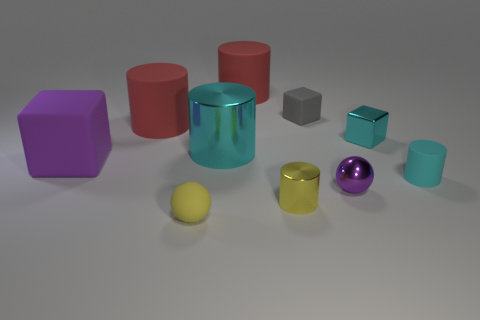Is the material of the purple sphere the same as the gray object?
Offer a very short reply. No. The tiny object that is the same color as the big cube is what shape?
Your response must be concise. Sphere. Are there more tiny metallic things that are in front of the big purple rubber block than purple balls?
Keep it short and to the point. Yes. There is a object that is behind the metal cube and to the left of the big shiny cylinder; what is its material?
Give a very brief answer. Rubber. There is a small thing in front of the yellow cylinder; does it have the same color as the cylinder that is in front of the purple ball?
Give a very brief answer. Yes. How many other things are the same size as the yellow cylinder?
Ensure brevity in your answer.  5. Is there a metal thing behind the big purple thing on the left side of the cyan metallic object to the left of the small cyan metallic object?
Your answer should be compact. Yes. Is the material of the small block that is behind the metallic block the same as the tiny purple sphere?
Offer a very short reply. No. What is the color of the small metal thing that is the same shape as the large metal thing?
Give a very brief answer. Yellow. Is the number of small rubber balls that are behind the big cyan cylinder the same as the number of small gray shiny cubes?
Offer a terse response. Yes. 